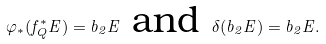<formula> <loc_0><loc_0><loc_500><loc_500>\varphi _ { * } ( f _ { Q } ^ { * } E ) = b _ { 2 } E \text { and } \delta ( b _ { 2 } E ) = b _ { 2 } E .</formula> 